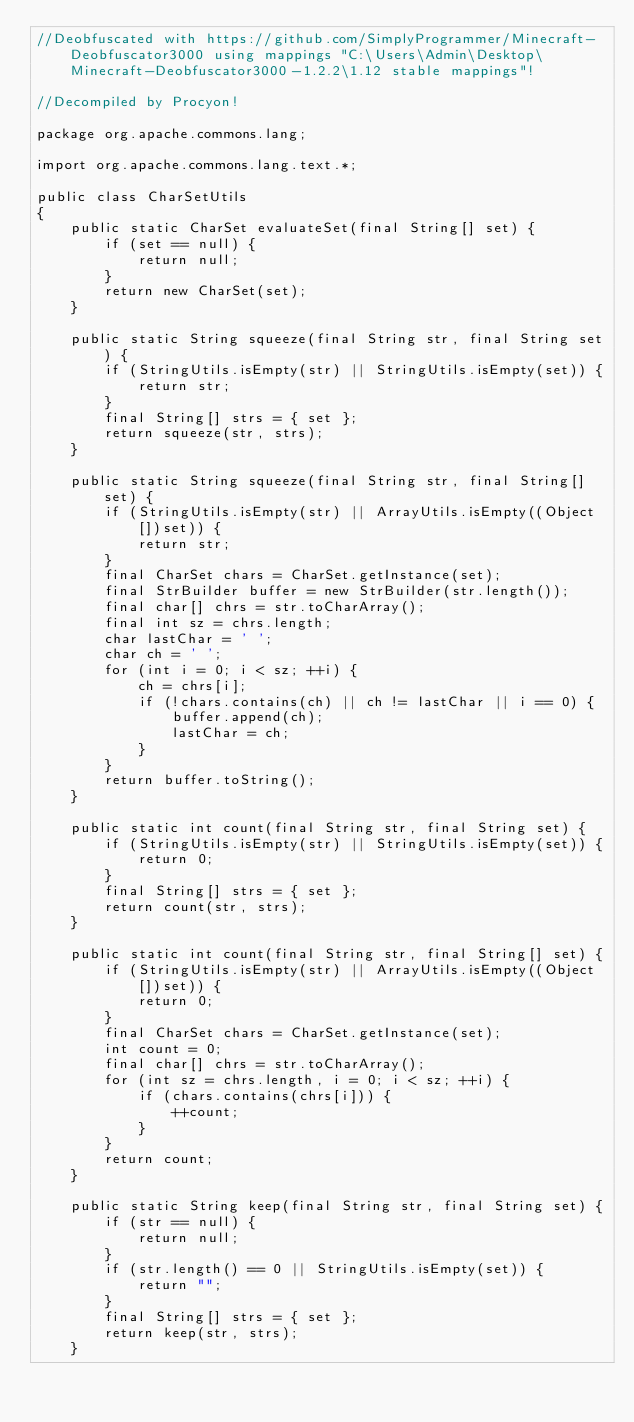<code> <loc_0><loc_0><loc_500><loc_500><_Java_>//Deobfuscated with https://github.com/SimplyProgrammer/Minecraft-Deobfuscator3000 using mappings "C:\Users\Admin\Desktop\Minecraft-Deobfuscator3000-1.2.2\1.12 stable mappings"!

//Decompiled by Procyon!

package org.apache.commons.lang;

import org.apache.commons.lang.text.*;

public class CharSetUtils
{
    public static CharSet evaluateSet(final String[] set) {
        if (set == null) {
            return null;
        }
        return new CharSet(set);
    }
    
    public static String squeeze(final String str, final String set) {
        if (StringUtils.isEmpty(str) || StringUtils.isEmpty(set)) {
            return str;
        }
        final String[] strs = { set };
        return squeeze(str, strs);
    }
    
    public static String squeeze(final String str, final String[] set) {
        if (StringUtils.isEmpty(str) || ArrayUtils.isEmpty((Object[])set)) {
            return str;
        }
        final CharSet chars = CharSet.getInstance(set);
        final StrBuilder buffer = new StrBuilder(str.length());
        final char[] chrs = str.toCharArray();
        final int sz = chrs.length;
        char lastChar = ' ';
        char ch = ' ';
        for (int i = 0; i < sz; ++i) {
            ch = chrs[i];
            if (!chars.contains(ch) || ch != lastChar || i == 0) {
                buffer.append(ch);
                lastChar = ch;
            }
        }
        return buffer.toString();
    }
    
    public static int count(final String str, final String set) {
        if (StringUtils.isEmpty(str) || StringUtils.isEmpty(set)) {
            return 0;
        }
        final String[] strs = { set };
        return count(str, strs);
    }
    
    public static int count(final String str, final String[] set) {
        if (StringUtils.isEmpty(str) || ArrayUtils.isEmpty((Object[])set)) {
            return 0;
        }
        final CharSet chars = CharSet.getInstance(set);
        int count = 0;
        final char[] chrs = str.toCharArray();
        for (int sz = chrs.length, i = 0; i < sz; ++i) {
            if (chars.contains(chrs[i])) {
                ++count;
            }
        }
        return count;
    }
    
    public static String keep(final String str, final String set) {
        if (str == null) {
            return null;
        }
        if (str.length() == 0 || StringUtils.isEmpty(set)) {
            return "";
        }
        final String[] strs = { set };
        return keep(str, strs);
    }
    </code> 